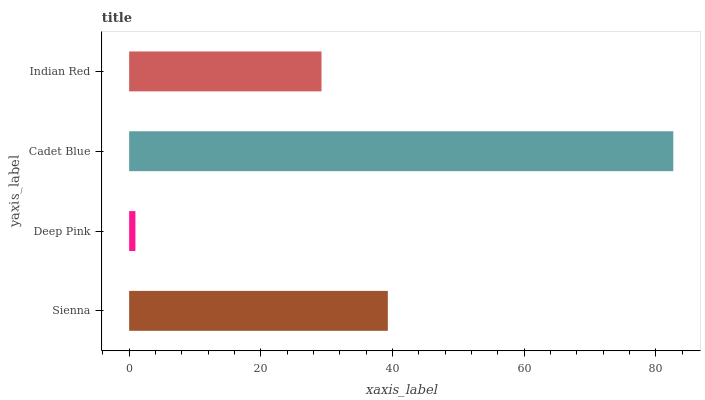Is Deep Pink the minimum?
Answer yes or no. Yes. Is Cadet Blue the maximum?
Answer yes or no. Yes. Is Cadet Blue the minimum?
Answer yes or no. No. Is Deep Pink the maximum?
Answer yes or no. No. Is Cadet Blue greater than Deep Pink?
Answer yes or no. Yes. Is Deep Pink less than Cadet Blue?
Answer yes or no. Yes. Is Deep Pink greater than Cadet Blue?
Answer yes or no. No. Is Cadet Blue less than Deep Pink?
Answer yes or no. No. Is Sienna the high median?
Answer yes or no. Yes. Is Indian Red the low median?
Answer yes or no. Yes. Is Indian Red the high median?
Answer yes or no. No. Is Deep Pink the low median?
Answer yes or no. No. 